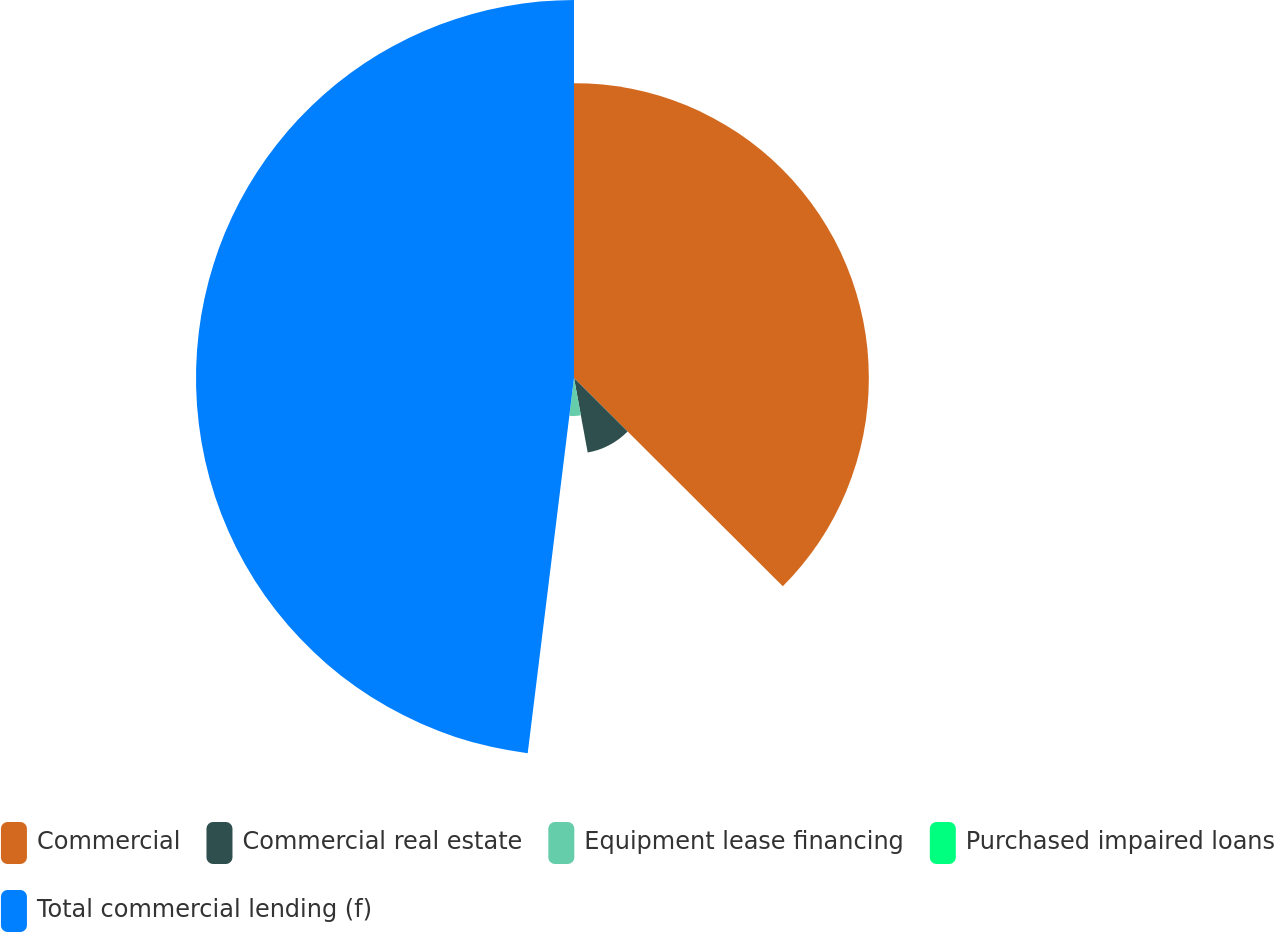Convert chart to OTSL. <chart><loc_0><loc_0><loc_500><loc_500><pie_chart><fcel>Commercial<fcel>Commercial real estate<fcel>Equipment lease financing<fcel>Purchased impaired loans<fcel>Total commercial lending (f)<nl><fcel>37.48%<fcel>9.63%<fcel>4.83%<fcel>0.02%<fcel>48.05%<nl></chart> 